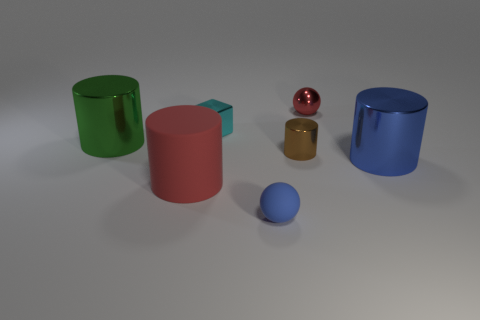Subtract 1 cylinders. How many cylinders are left? 3 Subtract all blue cylinders. How many cylinders are left? 3 Subtract all large rubber cylinders. How many cylinders are left? 3 Subtract all cyan cylinders. Subtract all blue cubes. How many cylinders are left? 4 Add 3 tiny brown metal cylinders. How many objects exist? 10 Subtract all spheres. How many objects are left? 5 Subtract 0 green cubes. How many objects are left? 7 Subtract all green matte cubes. Subtract all cubes. How many objects are left? 6 Add 5 red balls. How many red balls are left? 6 Add 6 brown rubber cylinders. How many brown rubber cylinders exist? 6 